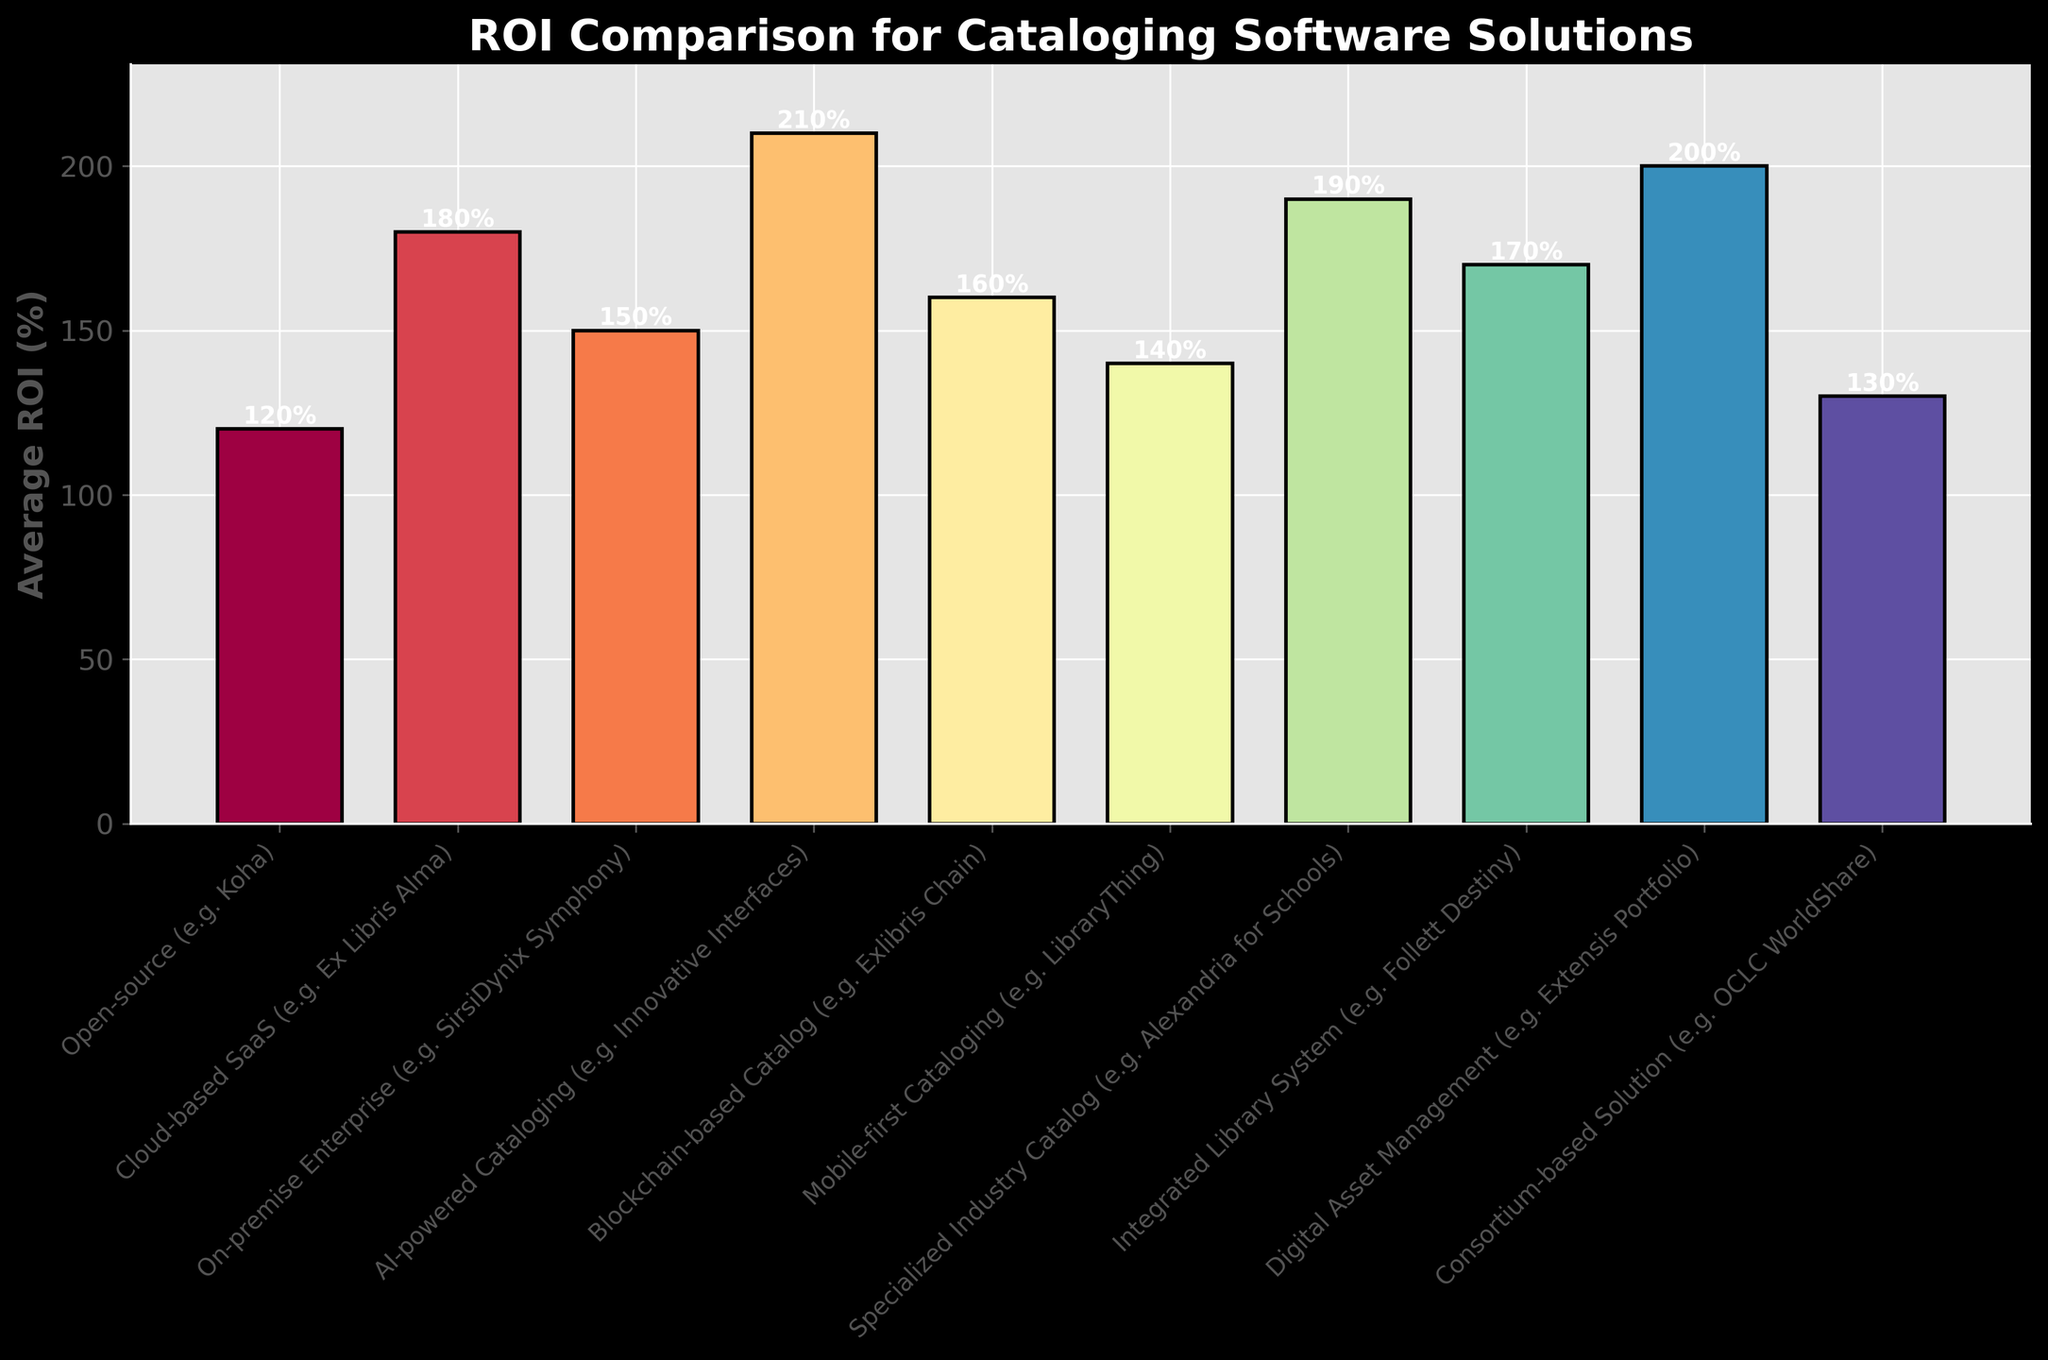Which cataloging software solution has the highest ROI? The AI-powered Cataloging solution has the highest bar in the figure, indicating that it has the highest ROI.
Answer: AI-powered Cataloging What is the difference in ROI between the Open-source and the Cloud-based SaaS solutions? The ROI for Open-source is 120%, and for Cloud-based SaaS it is 180%. The difference is obtained by subtracting 120% from 180%, resulting in 60%.
Answer: 60% Which two types of solutions have the nearest ROI values? The Blockchain-based Catalog and Integrated Library System have the nearest ROI values. Blockchain-based Catalog has 160% and Integrated Library System has 170%, making their difference just 10%.
Answer: Blockchain-based Catalog and Integrated Library System What is the average ROI of the top three solutions? The top three solutions by ROI are AI-powered Cataloging (210%), Digital Asset Management (200%), and Specialized Industry Catalog (190%). The sum of these ROIs is 210% + 200% + 190% = 600%. Dividing by 3 gives 600% / 3 = 200%.
Answer: 200% How does the ROI of Mobile-first Cataloging compare to that of the Consortium-based Solution? The ROI of Mobile-first Cataloging is 140%, whereas for the Consortium-based Solution it is 130%. Comparing both, Mobile-first Cataloging has a higher ROI by 10%.
Answer: Mobile-first Cataloging has a higher ROI by 10% What is the sum of ROI values of the solutions with the lowest and highest ROIs? The solutions with the lowest and highest ROIs are Open-source (120%) and AI-powered Cataloging (210%), respectively. Adding them together gives 120% + 210% = 330%.
Answer: 330% Which software solution is represented by the darkest shade in the plot? The AI-powered Cataloging solution is represented by the tallest bar with the darkest shade in the plot, indicating the highest ROI.
Answer: AI-powered Cataloging If we consider the solutions with an ROI equal to or higher than 180%, how many solutions fall into this category? The solutions with an ROI equal to or higher than 180% are Cloud-based SaaS, Specialized Industry Catalog, Digital Asset Management, and AI-powered Cataloging. There are 4 such solutions in total.
Answer: 4 What is the range of the ROI values displayed in the figure? The range is the difference between the maximum and minimum values. The maximum ROI is 210% (AI-powered Cataloging) and the minimum ROI is 120% (Open-source). The range is 210% - 120% = 90%.
Answer: 90% 